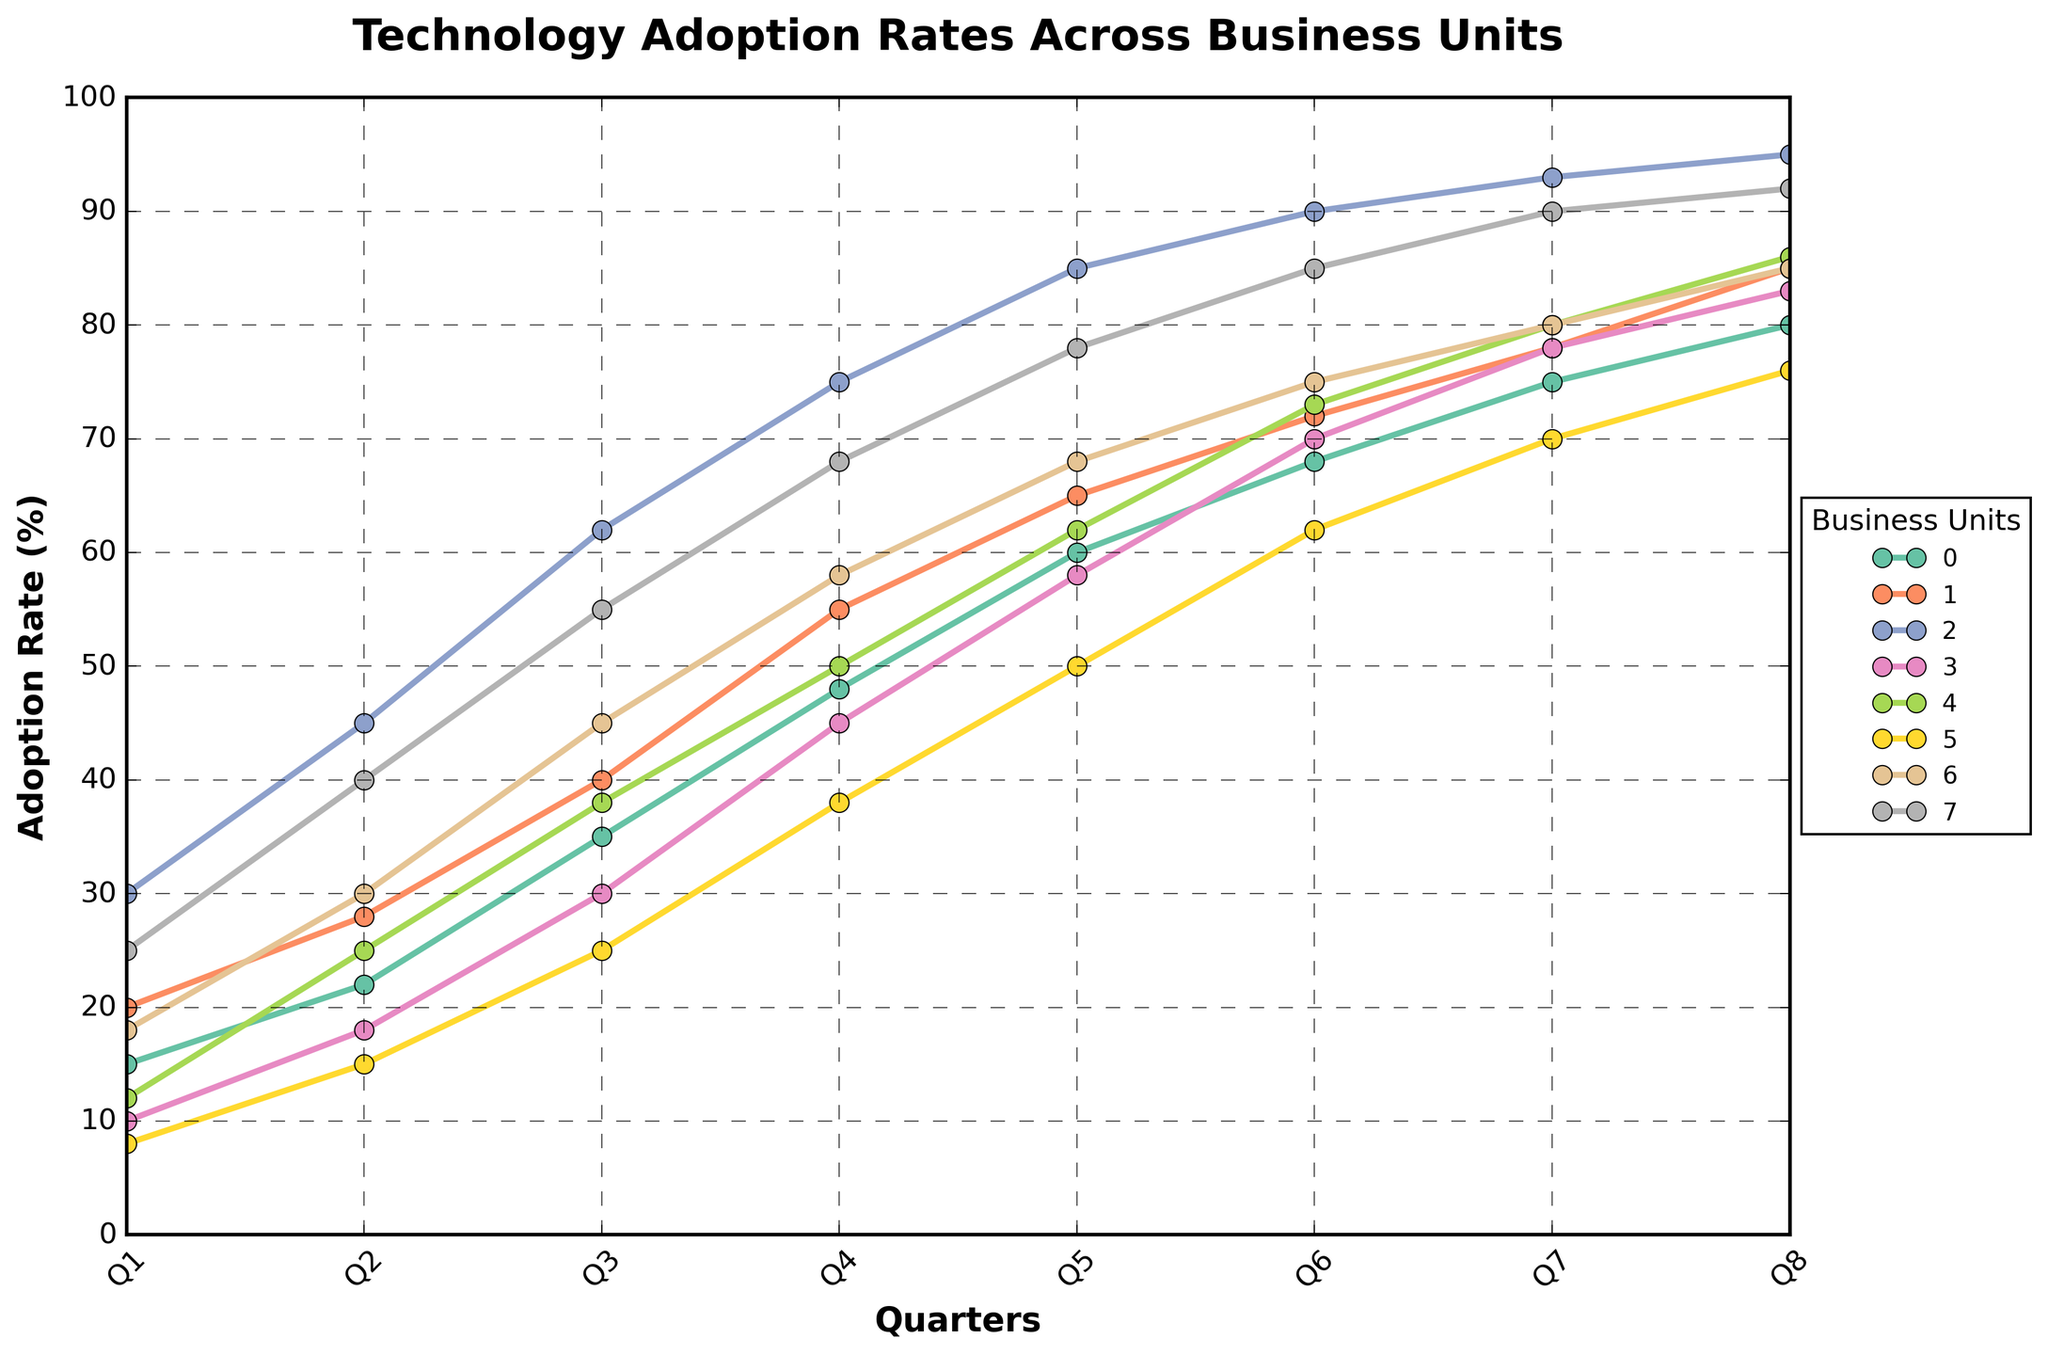What are the adoption rates for Marketing and IT in Q4? In Q4, the adoption rates for Marketing and IT can be read directly from the figure. Marketing has an adoption rate of 55%, and IT has an adoption rate of 75%.
Answer: Marketing: 55%, IT: 75% Which business unit had the highest adoption rate in Q7, and what was the rate? The highest adoption rate in Q7 can be observed from the figure. IT has the highest adoption rate at 93%.
Answer: IT: 93% What is the average adoption rate across all business units in Q2? Sum the adoption rates in Q2 for all business units: 22 + 28 + 45 + 18 + 25 + 15 + 30 + 40 = 223. Divide by 8 (the number of business units) to get the average: 223 / 8 = 27.875
Answer: 27.875% Between Q5 and Q8, which business unit shows the smallest increase in adoption rate, and by how much? Calculate the increase for each unit from Q5 to Q8 and identify the smallest one.
- Sales: 80 - 60 = 20
- Marketing: 85 - 65 = 20
- IT: 95 - 85 = 10
- Customer Service: 83 - 58 = 25
- Operations: 86 - 62 = 24
- Human Resources: 76 - 50 = 26
- Finance: 85 - 68 = 17
- Research & Development: 92 - 78 = 14
The smallest increase is exhibited by IT with an increase of 10%.
Answer: IT: 10% Which business unit had the lowest adoption rate in Q1 and what was the rate? The lowest adoption rate in Q1 is observed from the figure. Human Resources had the lowest at 8%.
Answer: Human Resources: 8% Which quarters had the highest and lowest adoption rates for Customer Service, and what were the rates? Identify the highest and lowest adoption rates for Customer Service from the figure.
- Highest: Q8 at 83%
- Lowest: Q1 at 10%
Answer: Highest: Q8 (83%), Lowest: Q1 (10%) What is the total increase in adoption rate for Finance from Q1 to Q8? Calculate the difference between the adoption rates in Q1 and Q8 for Finance.
- In Q1, Finance has an adoption rate of 18%.
- In Q8, Finance has an adoption rate of 85%.
Total increase = 85 - 18 = 67
Answer: 67% How many business units had an adoption rate of 70% or more by Q6? From the figure, count the number of business units with an adoption rate of 70% or more in Q6.
- IT: 90
- Customer Service: 70
- Marketing: 72
- Operations: 73
- Finance: 75
- Research & Development: 85
There are 6 business units.
Answer: 6 Compare the adoption rates of Sales and Marketing in Q8. Which unit had a higher rate and by how much? From the figure, compare the adoption rates in Q8.
- Sales: 80%
- Marketing: 85%
Marketing has a higher rate by 85 - 80 = 5%.
Answer: Marketing: 5% higher Which business unit exhibited the most consistent increase in adoption rate over the quarters, and how can you tell? Consistent increase implies a steady rise without sharp drops. By visually examining the lines, IT shows the most consistent increase, with a relatively smooth and steady rise each quarter.
Answer: IT 